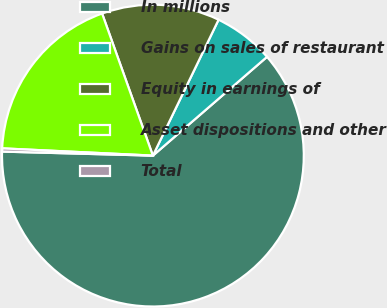Convert chart to OTSL. <chart><loc_0><loc_0><loc_500><loc_500><pie_chart><fcel>In millions<fcel>Gains on sales of restaurant<fcel>Equity in earnings of<fcel>Asset dispositions and other<fcel>Total<nl><fcel>61.78%<fcel>6.48%<fcel>12.63%<fcel>18.77%<fcel>0.34%<nl></chart> 